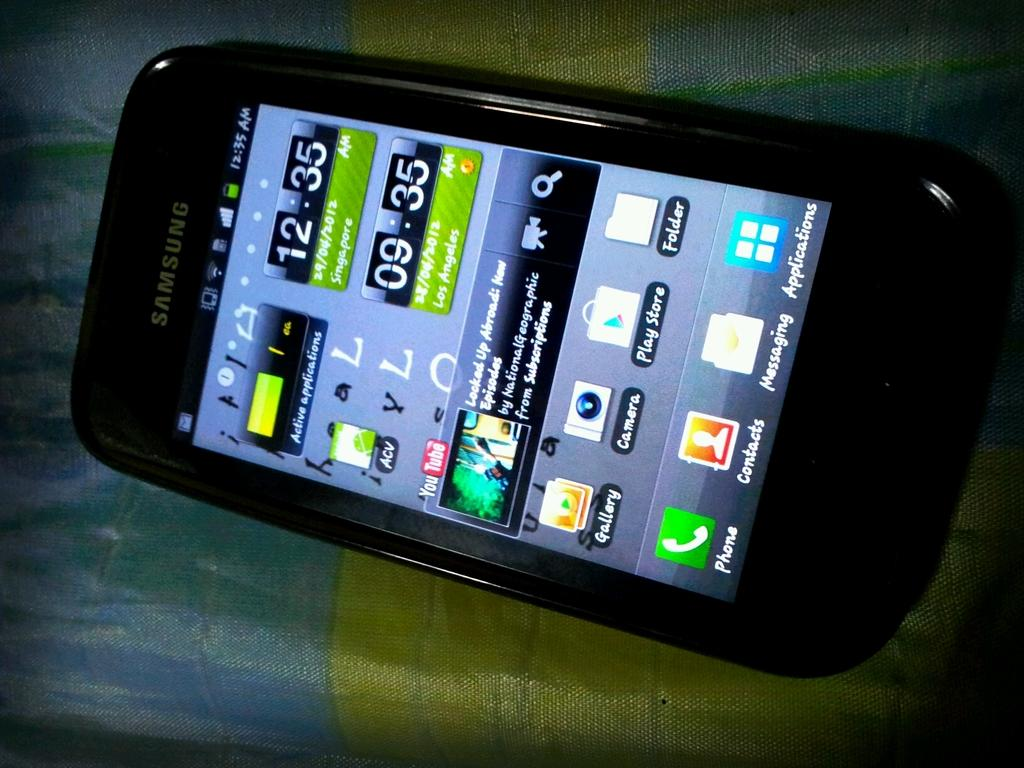<image>
Write a terse but informative summary of the picture. A phone includes an app called ACV, and a YouTube app. 